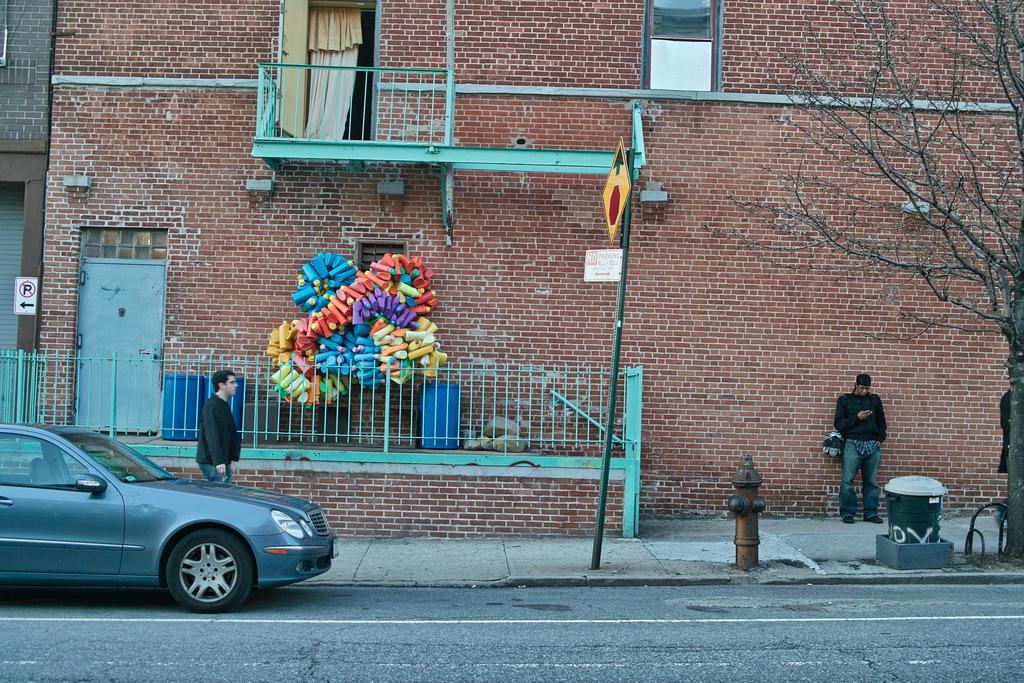What type of structures can be seen in the image? There are buildings in the image. What additional features are present on the buildings? Signboards, doors, and railings are visible on the buildings. Can you describe any other objects in the image? There is a pole, a curtain, a hydrant, a bin, and a tree in the image. Are there any vehicles present in the image? Yes, a vehicle is present in the image. What else can be seen in the image? There are people and objects visible in the image. What type of religion is practiced in the image? There is no indication of any religious practice or belief in the image. What degree of education is required to understand the image? The image does not require any specific degree of education to understand it. 